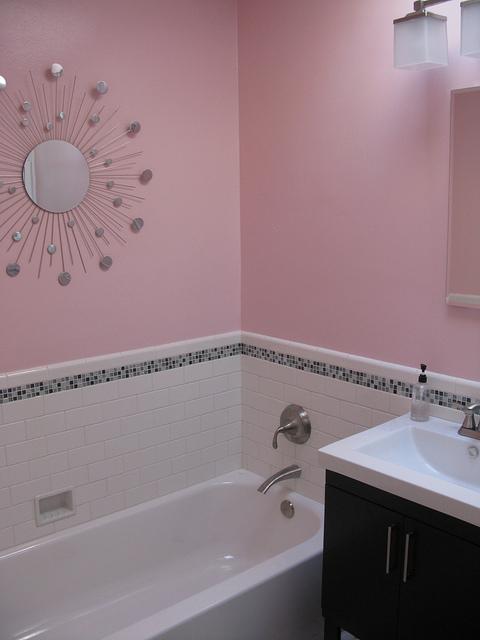What color is the bathtub?
Give a very brief answer. White. What color are the walls painted?
Be succinct. Pink. What color are the cabinet doors?
Write a very short answer. Black. 